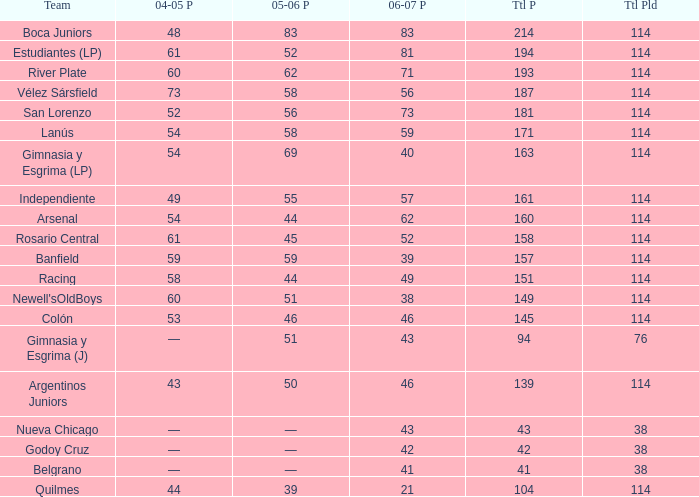What is the total number of points for a total pld less than 38? 0.0. 